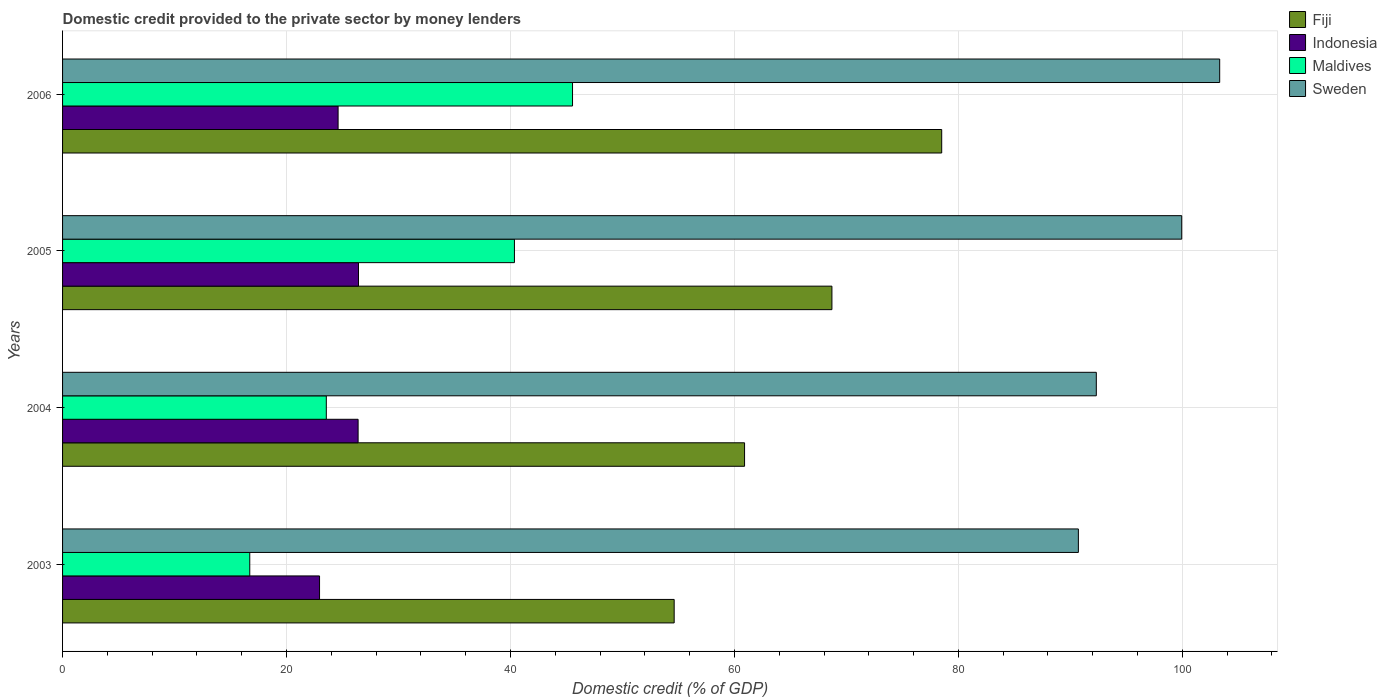How many different coloured bars are there?
Give a very brief answer. 4. How many bars are there on the 1st tick from the top?
Offer a terse response. 4. In how many cases, is the number of bars for a given year not equal to the number of legend labels?
Your answer should be compact. 0. What is the domestic credit provided to the private sector by money lenders in Maldives in 2006?
Keep it short and to the point. 45.54. Across all years, what is the maximum domestic credit provided to the private sector by money lenders in Fiji?
Ensure brevity in your answer.  78.51. Across all years, what is the minimum domestic credit provided to the private sector by money lenders in Indonesia?
Keep it short and to the point. 22.95. In which year was the domestic credit provided to the private sector by money lenders in Maldives maximum?
Keep it short and to the point. 2006. In which year was the domestic credit provided to the private sector by money lenders in Fiji minimum?
Your answer should be compact. 2003. What is the total domestic credit provided to the private sector by money lenders in Sweden in the graph?
Ensure brevity in your answer.  386.31. What is the difference between the domestic credit provided to the private sector by money lenders in Indonesia in 2004 and that in 2005?
Make the answer very short. -0.04. What is the difference between the domestic credit provided to the private sector by money lenders in Maldives in 2004 and the domestic credit provided to the private sector by money lenders in Fiji in 2005?
Your response must be concise. -45.15. What is the average domestic credit provided to the private sector by money lenders in Sweden per year?
Keep it short and to the point. 96.58. In the year 2004, what is the difference between the domestic credit provided to the private sector by money lenders in Sweden and domestic credit provided to the private sector by money lenders in Indonesia?
Make the answer very short. 65.92. What is the ratio of the domestic credit provided to the private sector by money lenders in Fiji in 2004 to that in 2005?
Provide a short and direct response. 0.89. What is the difference between the highest and the second highest domestic credit provided to the private sector by money lenders in Indonesia?
Ensure brevity in your answer.  0.04. What is the difference between the highest and the lowest domestic credit provided to the private sector by money lenders in Maldives?
Provide a short and direct response. 28.82. In how many years, is the domestic credit provided to the private sector by money lenders in Maldives greater than the average domestic credit provided to the private sector by money lenders in Maldives taken over all years?
Make the answer very short. 2. Is the sum of the domestic credit provided to the private sector by money lenders in Maldives in 2005 and 2006 greater than the maximum domestic credit provided to the private sector by money lenders in Sweden across all years?
Your answer should be compact. No. What does the 4th bar from the top in 2005 represents?
Offer a terse response. Fiji. Are the values on the major ticks of X-axis written in scientific E-notation?
Provide a short and direct response. No. Does the graph contain any zero values?
Give a very brief answer. No. What is the title of the graph?
Provide a short and direct response. Domestic credit provided to the private sector by money lenders. Does "Algeria" appear as one of the legend labels in the graph?
Your response must be concise. No. What is the label or title of the X-axis?
Make the answer very short. Domestic credit (% of GDP). What is the Domestic credit (% of GDP) in Fiji in 2003?
Your answer should be very brief. 54.62. What is the Domestic credit (% of GDP) in Indonesia in 2003?
Make the answer very short. 22.95. What is the Domestic credit (% of GDP) in Maldives in 2003?
Your response must be concise. 16.72. What is the Domestic credit (% of GDP) in Sweden in 2003?
Provide a succinct answer. 90.72. What is the Domestic credit (% of GDP) in Fiji in 2004?
Give a very brief answer. 60.91. What is the Domestic credit (% of GDP) of Indonesia in 2004?
Offer a very short reply. 26.39. What is the Domestic credit (% of GDP) in Maldives in 2004?
Your answer should be very brief. 23.55. What is the Domestic credit (% of GDP) of Sweden in 2004?
Offer a terse response. 92.32. What is the Domestic credit (% of GDP) in Fiji in 2005?
Your response must be concise. 68.71. What is the Domestic credit (% of GDP) of Indonesia in 2005?
Offer a very short reply. 26.43. What is the Domestic credit (% of GDP) of Maldives in 2005?
Your response must be concise. 40.35. What is the Domestic credit (% of GDP) in Sweden in 2005?
Provide a short and direct response. 99.95. What is the Domestic credit (% of GDP) of Fiji in 2006?
Offer a terse response. 78.51. What is the Domestic credit (% of GDP) in Indonesia in 2006?
Provide a short and direct response. 24.61. What is the Domestic credit (% of GDP) of Maldives in 2006?
Keep it short and to the point. 45.54. What is the Domestic credit (% of GDP) in Sweden in 2006?
Offer a terse response. 103.33. Across all years, what is the maximum Domestic credit (% of GDP) of Fiji?
Make the answer very short. 78.51. Across all years, what is the maximum Domestic credit (% of GDP) of Indonesia?
Offer a terse response. 26.43. Across all years, what is the maximum Domestic credit (% of GDP) of Maldives?
Keep it short and to the point. 45.54. Across all years, what is the maximum Domestic credit (% of GDP) in Sweden?
Ensure brevity in your answer.  103.33. Across all years, what is the minimum Domestic credit (% of GDP) of Fiji?
Provide a succinct answer. 54.62. Across all years, what is the minimum Domestic credit (% of GDP) in Indonesia?
Offer a very short reply. 22.95. Across all years, what is the minimum Domestic credit (% of GDP) in Maldives?
Your response must be concise. 16.72. Across all years, what is the minimum Domestic credit (% of GDP) in Sweden?
Provide a short and direct response. 90.72. What is the total Domestic credit (% of GDP) of Fiji in the graph?
Your answer should be compact. 262.74. What is the total Domestic credit (% of GDP) in Indonesia in the graph?
Your answer should be compact. 100.38. What is the total Domestic credit (% of GDP) in Maldives in the graph?
Keep it short and to the point. 126.17. What is the total Domestic credit (% of GDP) of Sweden in the graph?
Offer a terse response. 386.31. What is the difference between the Domestic credit (% of GDP) in Fiji in 2003 and that in 2004?
Offer a terse response. -6.29. What is the difference between the Domestic credit (% of GDP) of Indonesia in 2003 and that in 2004?
Offer a terse response. -3.44. What is the difference between the Domestic credit (% of GDP) of Maldives in 2003 and that in 2004?
Your answer should be very brief. -6.84. What is the difference between the Domestic credit (% of GDP) of Sweden in 2003 and that in 2004?
Offer a terse response. -1.6. What is the difference between the Domestic credit (% of GDP) of Fiji in 2003 and that in 2005?
Your answer should be compact. -14.09. What is the difference between the Domestic credit (% of GDP) in Indonesia in 2003 and that in 2005?
Provide a succinct answer. -3.48. What is the difference between the Domestic credit (% of GDP) in Maldives in 2003 and that in 2005?
Offer a very short reply. -23.64. What is the difference between the Domestic credit (% of GDP) of Sweden in 2003 and that in 2005?
Provide a succinct answer. -9.23. What is the difference between the Domestic credit (% of GDP) of Fiji in 2003 and that in 2006?
Ensure brevity in your answer.  -23.89. What is the difference between the Domestic credit (% of GDP) in Indonesia in 2003 and that in 2006?
Provide a succinct answer. -1.66. What is the difference between the Domestic credit (% of GDP) in Maldives in 2003 and that in 2006?
Offer a terse response. -28.82. What is the difference between the Domestic credit (% of GDP) of Sweden in 2003 and that in 2006?
Make the answer very short. -12.62. What is the difference between the Domestic credit (% of GDP) of Fiji in 2004 and that in 2005?
Ensure brevity in your answer.  -7.8. What is the difference between the Domestic credit (% of GDP) in Indonesia in 2004 and that in 2005?
Offer a terse response. -0.04. What is the difference between the Domestic credit (% of GDP) in Maldives in 2004 and that in 2005?
Your answer should be compact. -16.8. What is the difference between the Domestic credit (% of GDP) in Sweden in 2004 and that in 2005?
Give a very brief answer. -7.63. What is the difference between the Domestic credit (% of GDP) in Fiji in 2004 and that in 2006?
Provide a short and direct response. -17.6. What is the difference between the Domestic credit (% of GDP) in Indonesia in 2004 and that in 2006?
Give a very brief answer. 1.79. What is the difference between the Domestic credit (% of GDP) of Maldives in 2004 and that in 2006?
Your answer should be very brief. -21.99. What is the difference between the Domestic credit (% of GDP) of Sweden in 2004 and that in 2006?
Your answer should be very brief. -11.02. What is the difference between the Domestic credit (% of GDP) of Fiji in 2005 and that in 2006?
Your answer should be compact. -9.8. What is the difference between the Domestic credit (% of GDP) of Indonesia in 2005 and that in 2006?
Ensure brevity in your answer.  1.82. What is the difference between the Domestic credit (% of GDP) of Maldives in 2005 and that in 2006?
Keep it short and to the point. -5.19. What is the difference between the Domestic credit (% of GDP) of Sweden in 2005 and that in 2006?
Your answer should be very brief. -3.39. What is the difference between the Domestic credit (% of GDP) in Fiji in 2003 and the Domestic credit (% of GDP) in Indonesia in 2004?
Give a very brief answer. 28.23. What is the difference between the Domestic credit (% of GDP) of Fiji in 2003 and the Domestic credit (% of GDP) of Maldives in 2004?
Offer a very short reply. 31.07. What is the difference between the Domestic credit (% of GDP) in Fiji in 2003 and the Domestic credit (% of GDP) in Sweden in 2004?
Provide a short and direct response. -37.7. What is the difference between the Domestic credit (% of GDP) of Indonesia in 2003 and the Domestic credit (% of GDP) of Maldives in 2004?
Offer a very short reply. -0.6. What is the difference between the Domestic credit (% of GDP) of Indonesia in 2003 and the Domestic credit (% of GDP) of Sweden in 2004?
Ensure brevity in your answer.  -69.37. What is the difference between the Domestic credit (% of GDP) in Maldives in 2003 and the Domestic credit (% of GDP) in Sweden in 2004?
Ensure brevity in your answer.  -75.6. What is the difference between the Domestic credit (% of GDP) in Fiji in 2003 and the Domestic credit (% of GDP) in Indonesia in 2005?
Give a very brief answer. 28.19. What is the difference between the Domestic credit (% of GDP) of Fiji in 2003 and the Domestic credit (% of GDP) of Maldives in 2005?
Make the answer very short. 14.27. What is the difference between the Domestic credit (% of GDP) of Fiji in 2003 and the Domestic credit (% of GDP) of Sweden in 2005?
Ensure brevity in your answer.  -45.33. What is the difference between the Domestic credit (% of GDP) in Indonesia in 2003 and the Domestic credit (% of GDP) in Maldives in 2005?
Offer a terse response. -17.4. What is the difference between the Domestic credit (% of GDP) in Indonesia in 2003 and the Domestic credit (% of GDP) in Sweden in 2005?
Provide a short and direct response. -77. What is the difference between the Domestic credit (% of GDP) in Maldives in 2003 and the Domestic credit (% of GDP) in Sweden in 2005?
Provide a succinct answer. -83.23. What is the difference between the Domestic credit (% of GDP) of Fiji in 2003 and the Domestic credit (% of GDP) of Indonesia in 2006?
Keep it short and to the point. 30.01. What is the difference between the Domestic credit (% of GDP) in Fiji in 2003 and the Domestic credit (% of GDP) in Maldives in 2006?
Provide a short and direct response. 9.08. What is the difference between the Domestic credit (% of GDP) of Fiji in 2003 and the Domestic credit (% of GDP) of Sweden in 2006?
Your answer should be compact. -48.72. What is the difference between the Domestic credit (% of GDP) in Indonesia in 2003 and the Domestic credit (% of GDP) in Maldives in 2006?
Your answer should be compact. -22.59. What is the difference between the Domestic credit (% of GDP) of Indonesia in 2003 and the Domestic credit (% of GDP) of Sweden in 2006?
Offer a terse response. -80.39. What is the difference between the Domestic credit (% of GDP) in Maldives in 2003 and the Domestic credit (% of GDP) in Sweden in 2006?
Provide a short and direct response. -86.62. What is the difference between the Domestic credit (% of GDP) in Fiji in 2004 and the Domestic credit (% of GDP) in Indonesia in 2005?
Provide a short and direct response. 34.48. What is the difference between the Domestic credit (% of GDP) of Fiji in 2004 and the Domestic credit (% of GDP) of Maldives in 2005?
Ensure brevity in your answer.  20.55. What is the difference between the Domestic credit (% of GDP) of Fiji in 2004 and the Domestic credit (% of GDP) of Sweden in 2005?
Ensure brevity in your answer.  -39.04. What is the difference between the Domestic credit (% of GDP) in Indonesia in 2004 and the Domestic credit (% of GDP) in Maldives in 2005?
Provide a succinct answer. -13.96. What is the difference between the Domestic credit (% of GDP) of Indonesia in 2004 and the Domestic credit (% of GDP) of Sweden in 2005?
Your answer should be very brief. -73.55. What is the difference between the Domestic credit (% of GDP) of Maldives in 2004 and the Domestic credit (% of GDP) of Sweden in 2005?
Offer a very short reply. -76.39. What is the difference between the Domestic credit (% of GDP) in Fiji in 2004 and the Domestic credit (% of GDP) in Indonesia in 2006?
Your answer should be very brief. 36.3. What is the difference between the Domestic credit (% of GDP) in Fiji in 2004 and the Domestic credit (% of GDP) in Maldives in 2006?
Your response must be concise. 15.36. What is the difference between the Domestic credit (% of GDP) of Fiji in 2004 and the Domestic credit (% of GDP) of Sweden in 2006?
Your answer should be compact. -42.43. What is the difference between the Domestic credit (% of GDP) in Indonesia in 2004 and the Domestic credit (% of GDP) in Maldives in 2006?
Keep it short and to the point. -19.15. What is the difference between the Domestic credit (% of GDP) of Indonesia in 2004 and the Domestic credit (% of GDP) of Sweden in 2006?
Offer a terse response. -76.94. What is the difference between the Domestic credit (% of GDP) in Maldives in 2004 and the Domestic credit (% of GDP) in Sweden in 2006?
Make the answer very short. -79.78. What is the difference between the Domestic credit (% of GDP) in Fiji in 2005 and the Domestic credit (% of GDP) in Indonesia in 2006?
Make the answer very short. 44.1. What is the difference between the Domestic credit (% of GDP) in Fiji in 2005 and the Domestic credit (% of GDP) in Maldives in 2006?
Your answer should be compact. 23.16. What is the difference between the Domestic credit (% of GDP) of Fiji in 2005 and the Domestic credit (% of GDP) of Sweden in 2006?
Provide a short and direct response. -34.63. What is the difference between the Domestic credit (% of GDP) of Indonesia in 2005 and the Domestic credit (% of GDP) of Maldives in 2006?
Keep it short and to the point. -19.11. What is the difference between the Domestic credit (% of GDP) in Indonesia in 2005 and the Domestic credit (% of GDP) in Sweden in 2006?
Your answer should be very brief. -76.91. What is the difference between the Domestic credit (% of GDP) of Maldives in 2005 and the Domestic credit (% of GDP) of Sweden in 2006?
Make the answer very short. -62.98. What is the average Domestic credit (% of GDP) of Fiji per year?
Provide a short and direct response. 65.69. What is the average Domestic credit (% of GDP) of Indonesia per year?
Make the answer very short. 25.09. What is the average Domestic credit (% of GDP) in Maldives per year?
Your response must be concise. 31.54. What is the average Domestic credit (% of GDP) in Sweden per year?
Ensure brevity in your answer.  96.58. In the year 2003, what is the difference between the Domestic credit (% of GDP) of Fiji and Domestic credit (% of GDP) of Indonesia?
Give a very brief answer. 31.67. In the year 2003, what is the difference between the Domestic credit (% of GDP) in Fiji and Domestic credit (% of GDP) in Maldives?
Offer a terse response. 37.9. In the year 2003, what is the difference between the Domestic credit (% of GDP) in Fiji and Domestic credit (% of GDP) in Sweden?
Ensure brevity in your answer.  -36.1. In the year 2003, what is the difference between the Domestic credit (% of GDP) in Indonesia and Domestic credit (% of GDP) in Maldives?
Your response must be concise. 6.23. In the year 2003, what is the difference between the Domestic credit (% of GDP) in Indonesia and Domestic credit (% of GDP) in Sweden?
Your answer should be very brief. -67.77. In the year 2003, what is the difference between the Domestic credit (% of GDP) in Maldives and Domestic credit (% of GDP) in Sweden?
Your response must be concise. -74. In the year 2004, what is the difference between the Domestic credit (% of GDP) of Fiji and Domestic credit (% of GDP) of Indonesia?
Keep it short and to the point. 34.51. In the year 2004, what is the difference between the Domestic credit (% of GDP) in Fiji and Domestic credit (% of GDP) in Maldives?
Your answer should be compact. 37.35. In the year 2004, what is the difference between the Domestic credit (% of GDP) of Fiji and Domestic credit (% of GDP) of Sweden?
Ensure brevity in your answer.  -31.41. In the year 2004, what is the difference between the Domestic credit (% of GDP) in Indonesia and Domestic credit (% of GDP) in Maldives?
Your answer should be very brief. 2.84. In the year 2004, what is the difference between the Domestic credit (% of GDP) of Indonesia and Domestic credit (% of GDP) of Sweden?
Ensure brevity in your answer.  -65.92. In the year 2004, what is the difference between the Domestic credit (% of GDP) of Maldives and Domestic credit (% of GDP) of Sweden?
Offer a very short reply. -68.76. In the year 2005, what is the difference between the Domestic credit (% of GDP) in Fiji and Domestic credit (% of GDP) in Indonesia?
Provide a succinct answer. 42.28. In the year 2005, what is the difference between the Domestic credit (% of GDP) of Fiji and Domestic credit (% of GDP) of Maldives?
Offer a terse response. 28.35. In the year 2005, what is the difference between the Domestic credit (% of GDP) in Fiji and Domestic credit (% of GDP) in Sweden?
Offer a very short reply. -31.24. In the year 2005, what is the difference between the Domestic credit (% of GDP) of Indonesia and Domestic credit (% of GDP) of Maldives?
Give a very brief answer. -13.93. In the year 2005, what is the difference between the Domestic credit (% of GDP) of Indonesia and Domestic credit (% of GDP) of Sweden?
Your response must be concise. -73.52. In the year 2005, what is the difference between the Domestic credit (% of GDP) in Maldives and Domestic credit (% of GDP) in Sweden?
Ensure brevity in your answer.  -59.59. In the year 2006, what is the difference between the Domestic credit (% of GDP) in Fiji and Domestic credit (% of GDP) in Indonesia?
Offer a terse response. 53.9. In the year 2006, what is the difference between the Domestic credit (% of GDP) in Fiji and Domestic credit (% of GDP) in Maldives?
Offer a very short reply. 32.97. In the year 2006, what is the difference between the Domestic credit (% of GDP) in Fiji and Domestic credit (% of GDP) in Sweden?
Keep it short and to the point. -24.82. In the year 2006, what is the difference between the Domestic credit (% of GDP) in Indonesia and Domestic credit (% of GDP) in Maldives?
Your response must be concise. -20.94. In the year 2006, what is the difference between the Domestic credit (% of GDP) of Indonesia and Domestic credit (% of GDP) of Sweden?
Provide a succinct answer. -78.73. In the year 2006, what is the difference between the Domestic credit (% of GDP) of Maldives and Domestic credit (% of GDP) of Sweden?
Ensure brevity in your answer.  -57.79. What is the ratio of the Domestic credit (% of GDP) of Fiji in 2003 to that in 2004?
Your answer should be very brief. 0.9. What is the ratio of the Domestic credit (% of GDP) in Indonesia in 2003 to that in 2004?
Your answer should be very brief. 0.87. What is the ratio of the Domestic credit (% of GDP) in Maldives in 2003 to that in 2004?
Ensure brevity in your answer.  0.71. What is the ratio of the Domestic credit (% of GDP) of Sweden in 2003 to that in 2004?
Offer a terse response. 0.98. What is the ratio of the Domestic credit (% of GDP) of Fiji in 2003 to that in 2005?
Keep it short and to the point. 0.8. What is the ratio of the Domestic credit (% of GDP) in Indonesia in 2003 to that in 2005?
Keep it short and to the point. 0.87. What is the ratio of the Domestic credit (% of GDP) of Maldives in 2003 to that in 2005?
Provide a succinct answer. 0.41. What is the ratio of the Domestic credit (% of GDP) in Sweden in 2003 to that in 2005?
Ensure brevity in your answer.  0.91. What is the ratio of the Domestic credit (% of GDP) in Fiji in 2003 to that in 2006?
Give a very brief answer. 0.7. What is the ratio of the Domestic credit (% of GDP) in Indonesia in 2003 to that in 2006?
Provide a short and direct response. 0.93. What is the ratio of the Domestic credit (% of GDP) in Maldives in 2003 to that in 2006?
Ensure brevity in your answer.  0.37. What is the ratio of the Domestic credit (% of GDP) of Sweden in 2003 to that in 2006?
Your answer should be very brief. 0.88. What is the ratio of the Domestic credit (% of GDP) of Fiji in 2004 to that in 2005?
Provide a succinct answer. 0.89. What is the ratio of the Domestic credit (% of GDP) in Maldives in 2004 to that in 2005?
Your response must be concise. 0.58. What is the ratio of the Domestic credit (% of GDP) of Sweden in 2004 to that in 2005?
Provide a short and direct response. 0.92. What is the ratio of the Domestic credit (% of GDP) of Fiji in 2004 to that in 2006?
Your response must be concise. 0.78. What is the ratio of the Domestic credit (% of GDP) in Indonesia in 2004 to that in 2006?
Your response must be concise. 1.07. What is the ratio of the Domestic credit (% of GDP) in Maldives in 2004 to that in 2006?
Ensure brevity in your answer.  0.52. What is the ratio of the Domestic credit (% of GDP) of Sweden in 2004 to that in 2006?
Ensure brevity in your answer.  0.89. What is the ratio of the Domestic credit (% of GDP) of Fiji in 2005 to that in 2006?
Your response must be concise. 0.88. What is the ratio of the Domestic credit (% of GDP) in Indonesia in 2005 to that in 2006?
Offer a terse response. 1.07. What is the ratio of the Domestic credit (% of GDP) of Maldives in 2005 to that in 2006?
Your answer should be compact. 0.89. What is the ratio of the Domestic credit (% of GDP) of Sweden in 2005 to that in 2006?
Ensure brevity in your answer.  0.97. What is the difference between the highest and the second highest Domestic credit (% of GDP) of Fiji?
Your answer should be very brief. 9.8. What is the difference between the highest and the second highest Domestic credit (% of GDP) in Indonesia?
Provide a succinct answer. 0.04. What is the difference between the highest and the second highest Domestic credit (% of GDP) in Maldives?
Give a very brief answer. 5.19. What is the difference between the highest and the second highest Domestic credit (% of GDP) of Sweden?
Give a very brief answer. 3.39. What is the difference between the highest and the lowest Domestic credit (% of GDP) in Fiji?
Offer a very short reply. 23.89. What is the difference between the highest and the lowest Domestic credit (% of GDP) of Indonesia?
Provide a succinct answer. 3.48. What is the difference between the highest and the lowest Domestic credit (% of GDP) in Maldives?
Offer a terse response. 28.82. What is the difference between the highest and the lowest Domestic credit (% of GDP) of Sweden?
Offer a terse response. 12.62. 